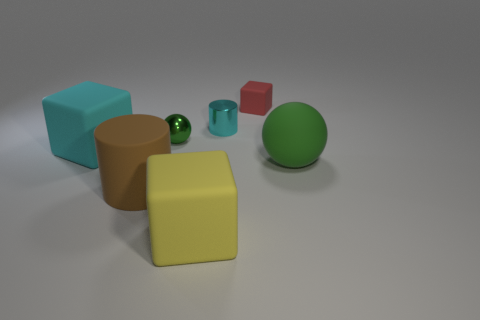What shape is the tiny red thing?
Your answer should be compact. Cube. What number of other things are the same material as the large cylinder?
Offer a very short reply. 4. There is a green metal object that is the same shape as the large green rubber thing; what size is it?
Offer a terse response. Small. What is the material of the green ball to the left of the block behind the big cyan matte thing that is behind the large green matte object?
Your response must be concise. Metal. Is there a big brown matte block?
Your answer should be very brief. No. There is a large sphere; does it have the same color as the ball left of the yellow thing?
Your answer should be very brief. Yes. The matte ball has what color?
Provide a succinct answer. Green. What color is the other shiny thing that is the same shape as the brown thing?
Make the answer very short. Cyan. Is the shape of the cyan shiny thing the same as the green rubber object?
Make the answer very short. No. How many balls are either big yellow objects or tiny matte things?
Your answer should be very brief. 0. 